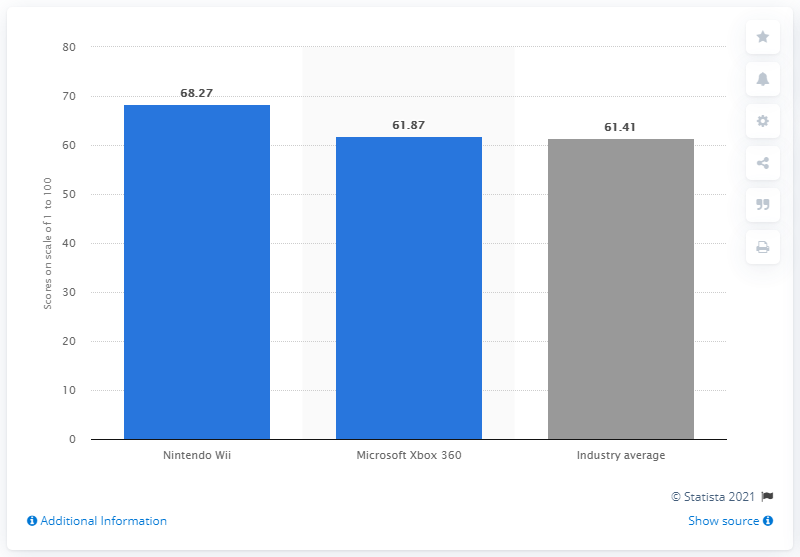What does the score of 68.27 indicate about Nintendo's performance in 2012 compared to its competitors? The score of 68.27 indicates that Nintendo's performance in 2012 was robust, ranking above its main competitor, Microsoft Xbox 360, and the industry average, which suggests a strong market position and favorable consumer perception during that year. 